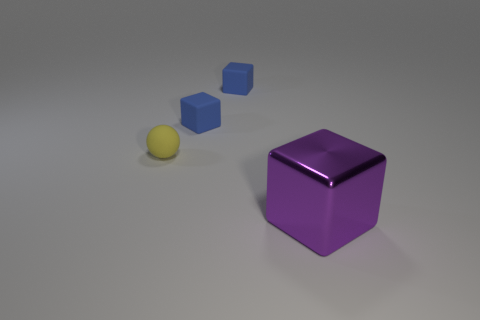There is an object in front of the tiny rubber ball; what is its shape? The object in front of the tiny rubber ball is a cube. Its distinct edges and faces reflect the light, giving it a 3D geometric look that is unmistakably that of a six-faced cube. 